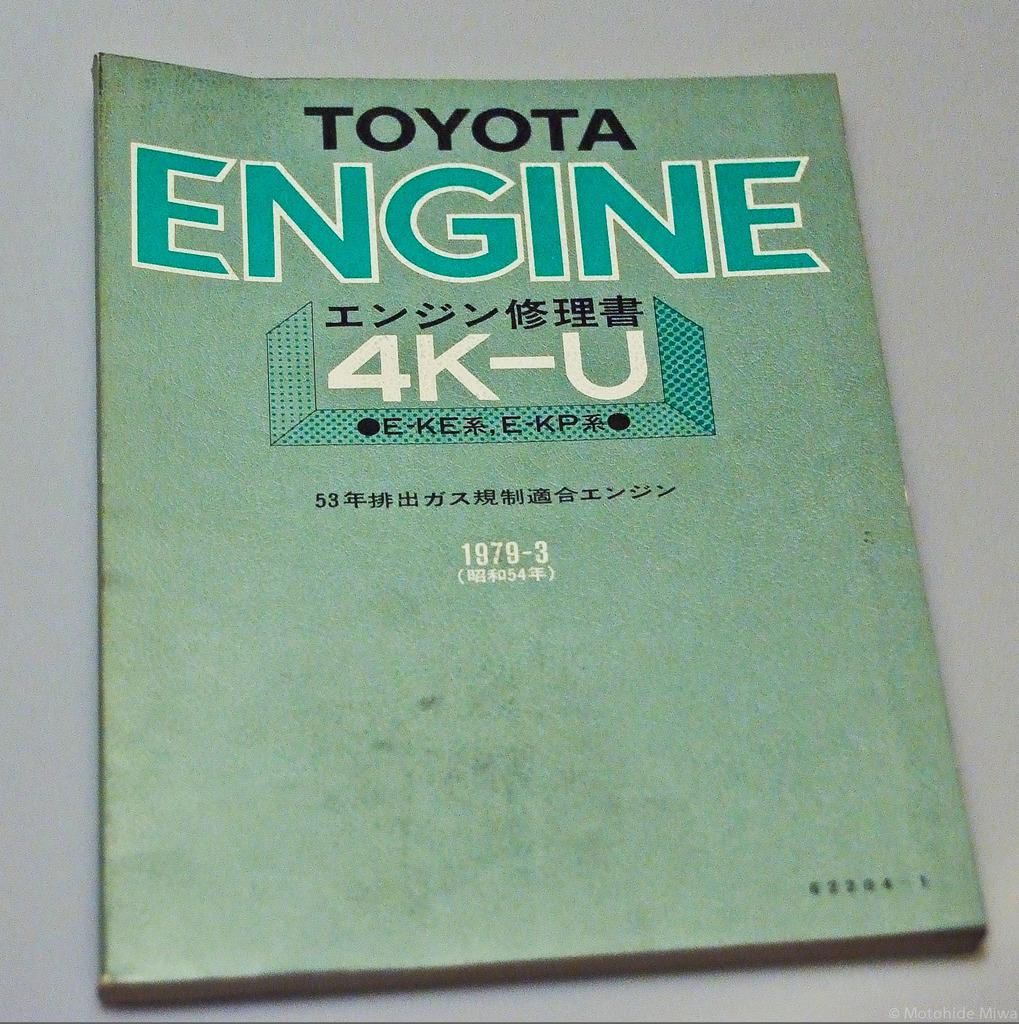Provide a one-sentence caption for the provided image. An old engine manual for a Toyota printed in Asian. 